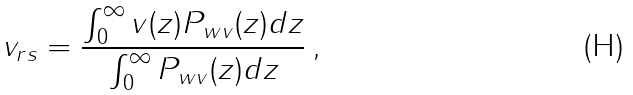Convert formula to latex. <formula><loc_0><loc_0><loc_500><loc_500>v _ { r s } = \frac { \int ^ { \infty } _ { 0 } v ( z ) P _ { w v } ( z ) d z } { \int ^ { \infty } _ { 0 } P _ { w v } ( z ) d z } \, ,</formula> 